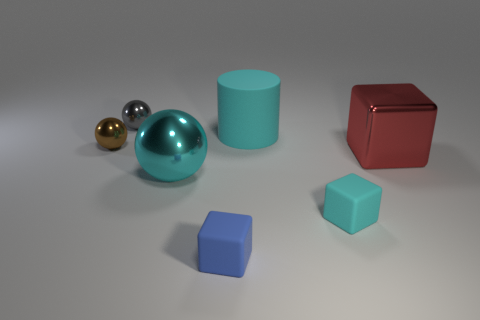What number of other things are there of the same shape as the brown shiny object?
Offer a terse response. 2. There is a rubber block behind the blue object; what color is it?
Your answer should be compact. Cyan. Is the size of the brown metal ball the same as the gray object?
Give a very brief answer. Yes. What is the material of the tiny thing that is behind the small ball that is in front of the tiny gray ball?
Ensure brevity in your answer.  Metal. How many things have the same color as the matte cylinder?
Give a very brief answer. 2. Is there any other thing that is made of the same material as the blue object?
Offer a terse response. Yes. Is the number of red shiny blocks left of the tiny blue block less than the number of gray cubes?
Provide a succinct answer. No. What is the color of the big metal object that is right of the cyan rubber cylinder behind the small brown metallic sphere?
Your response must be concise. Red. There is a metallic sphere that is in front of the large shiny thing right of the ball in front of the tiny brown metallic ball; what is its size?
Your response must be concise. Large. Are there fewer red cubes that are behind the large red block than small blue matte things that are left of the gray metallic thing?
Your answer should be compact. No. 